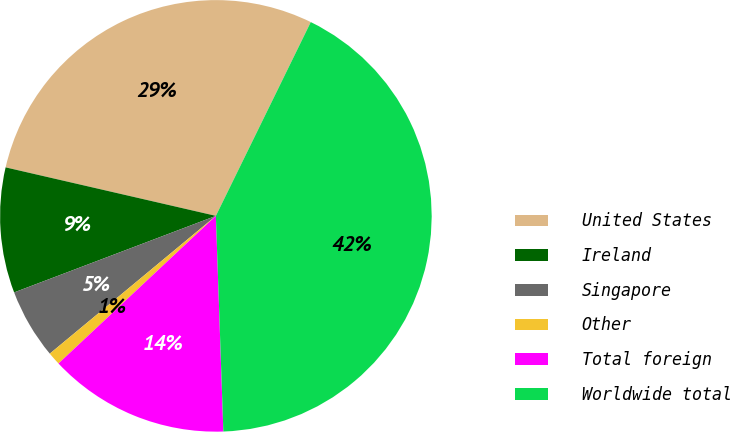Convert chart to OTSL. <chart><loc_0><loc_0><loc_500><loc_500><pie_chart><fcel>United States<fcel>Ireland<fcel>Singapore<fcel>Other<fcel>Total foreign<fcel>Worldwide total<nl><fcel>28.64%<fcel>9.38%<fcel>5.25%<fcel>0.97%<fcel>13.56%<fcel>42.2%<nl></chart> 